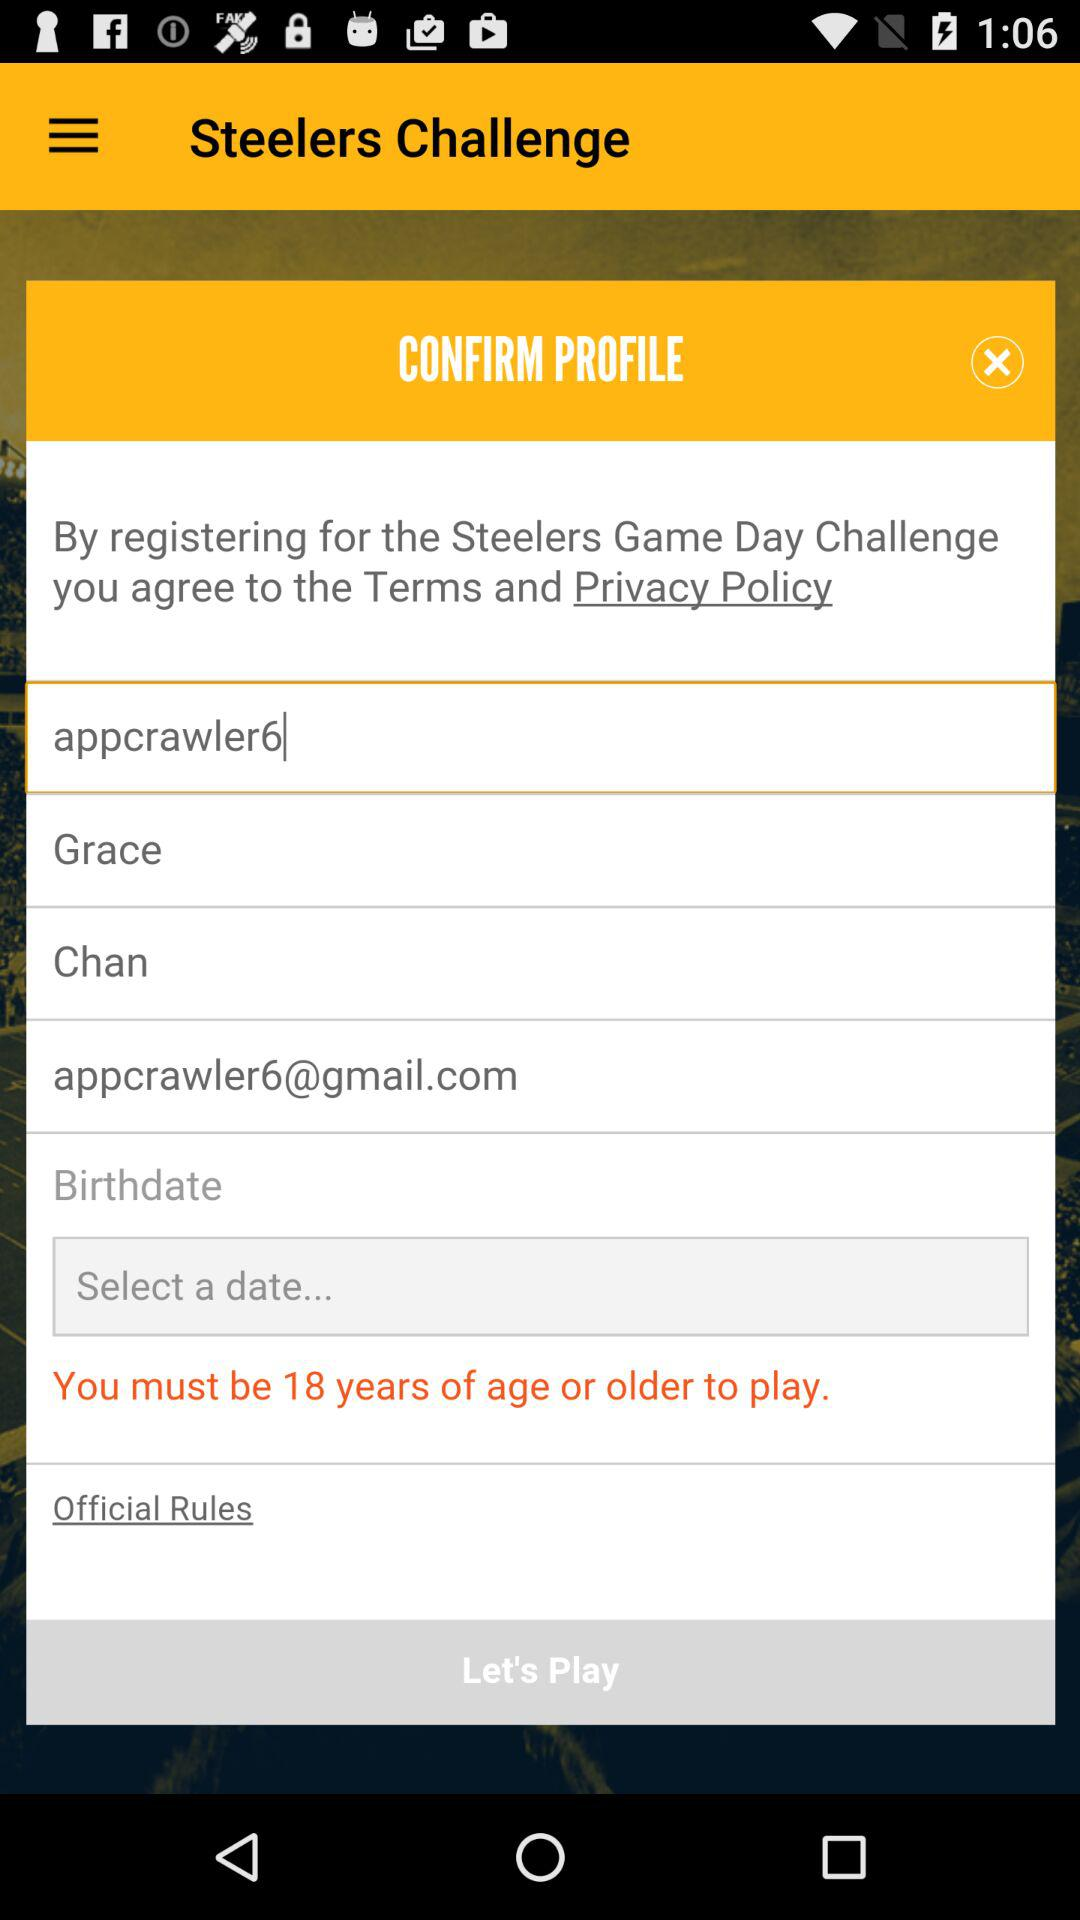How many text inputs are there for the user to fill out?
Answer the question using a single word or phrase. 5 